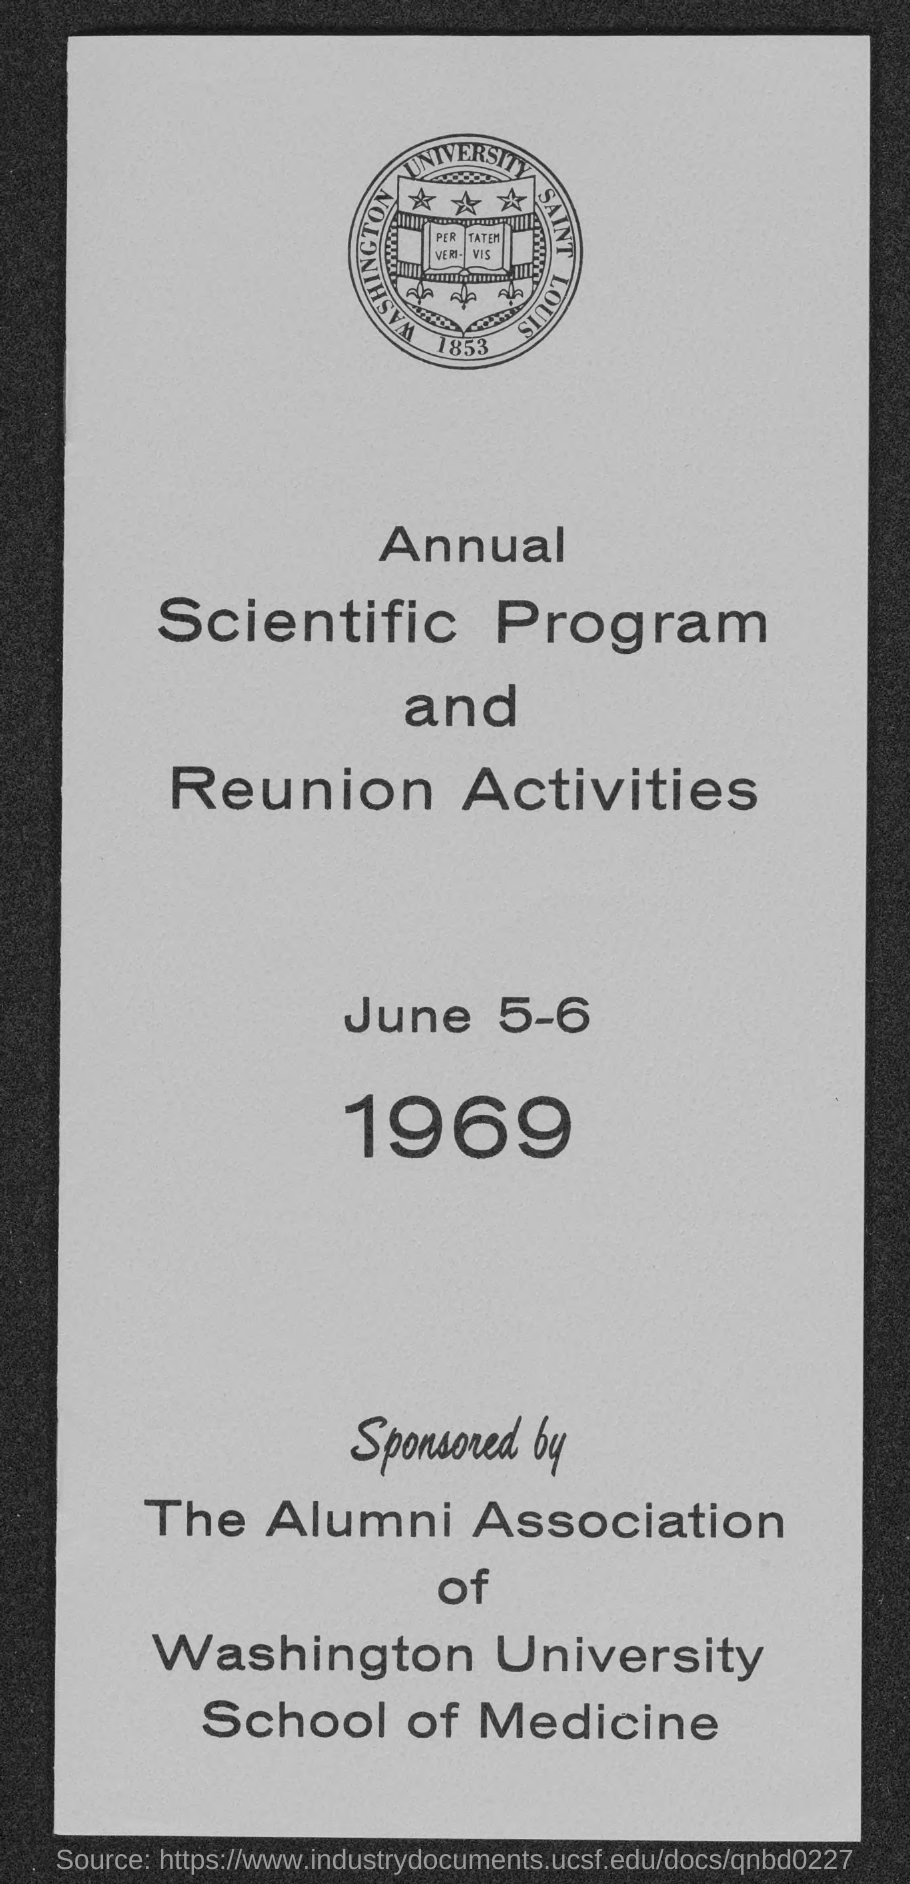When is the annual scientific program and reunion activities ?
Provide a succinct answer. June 5-6 1969. 